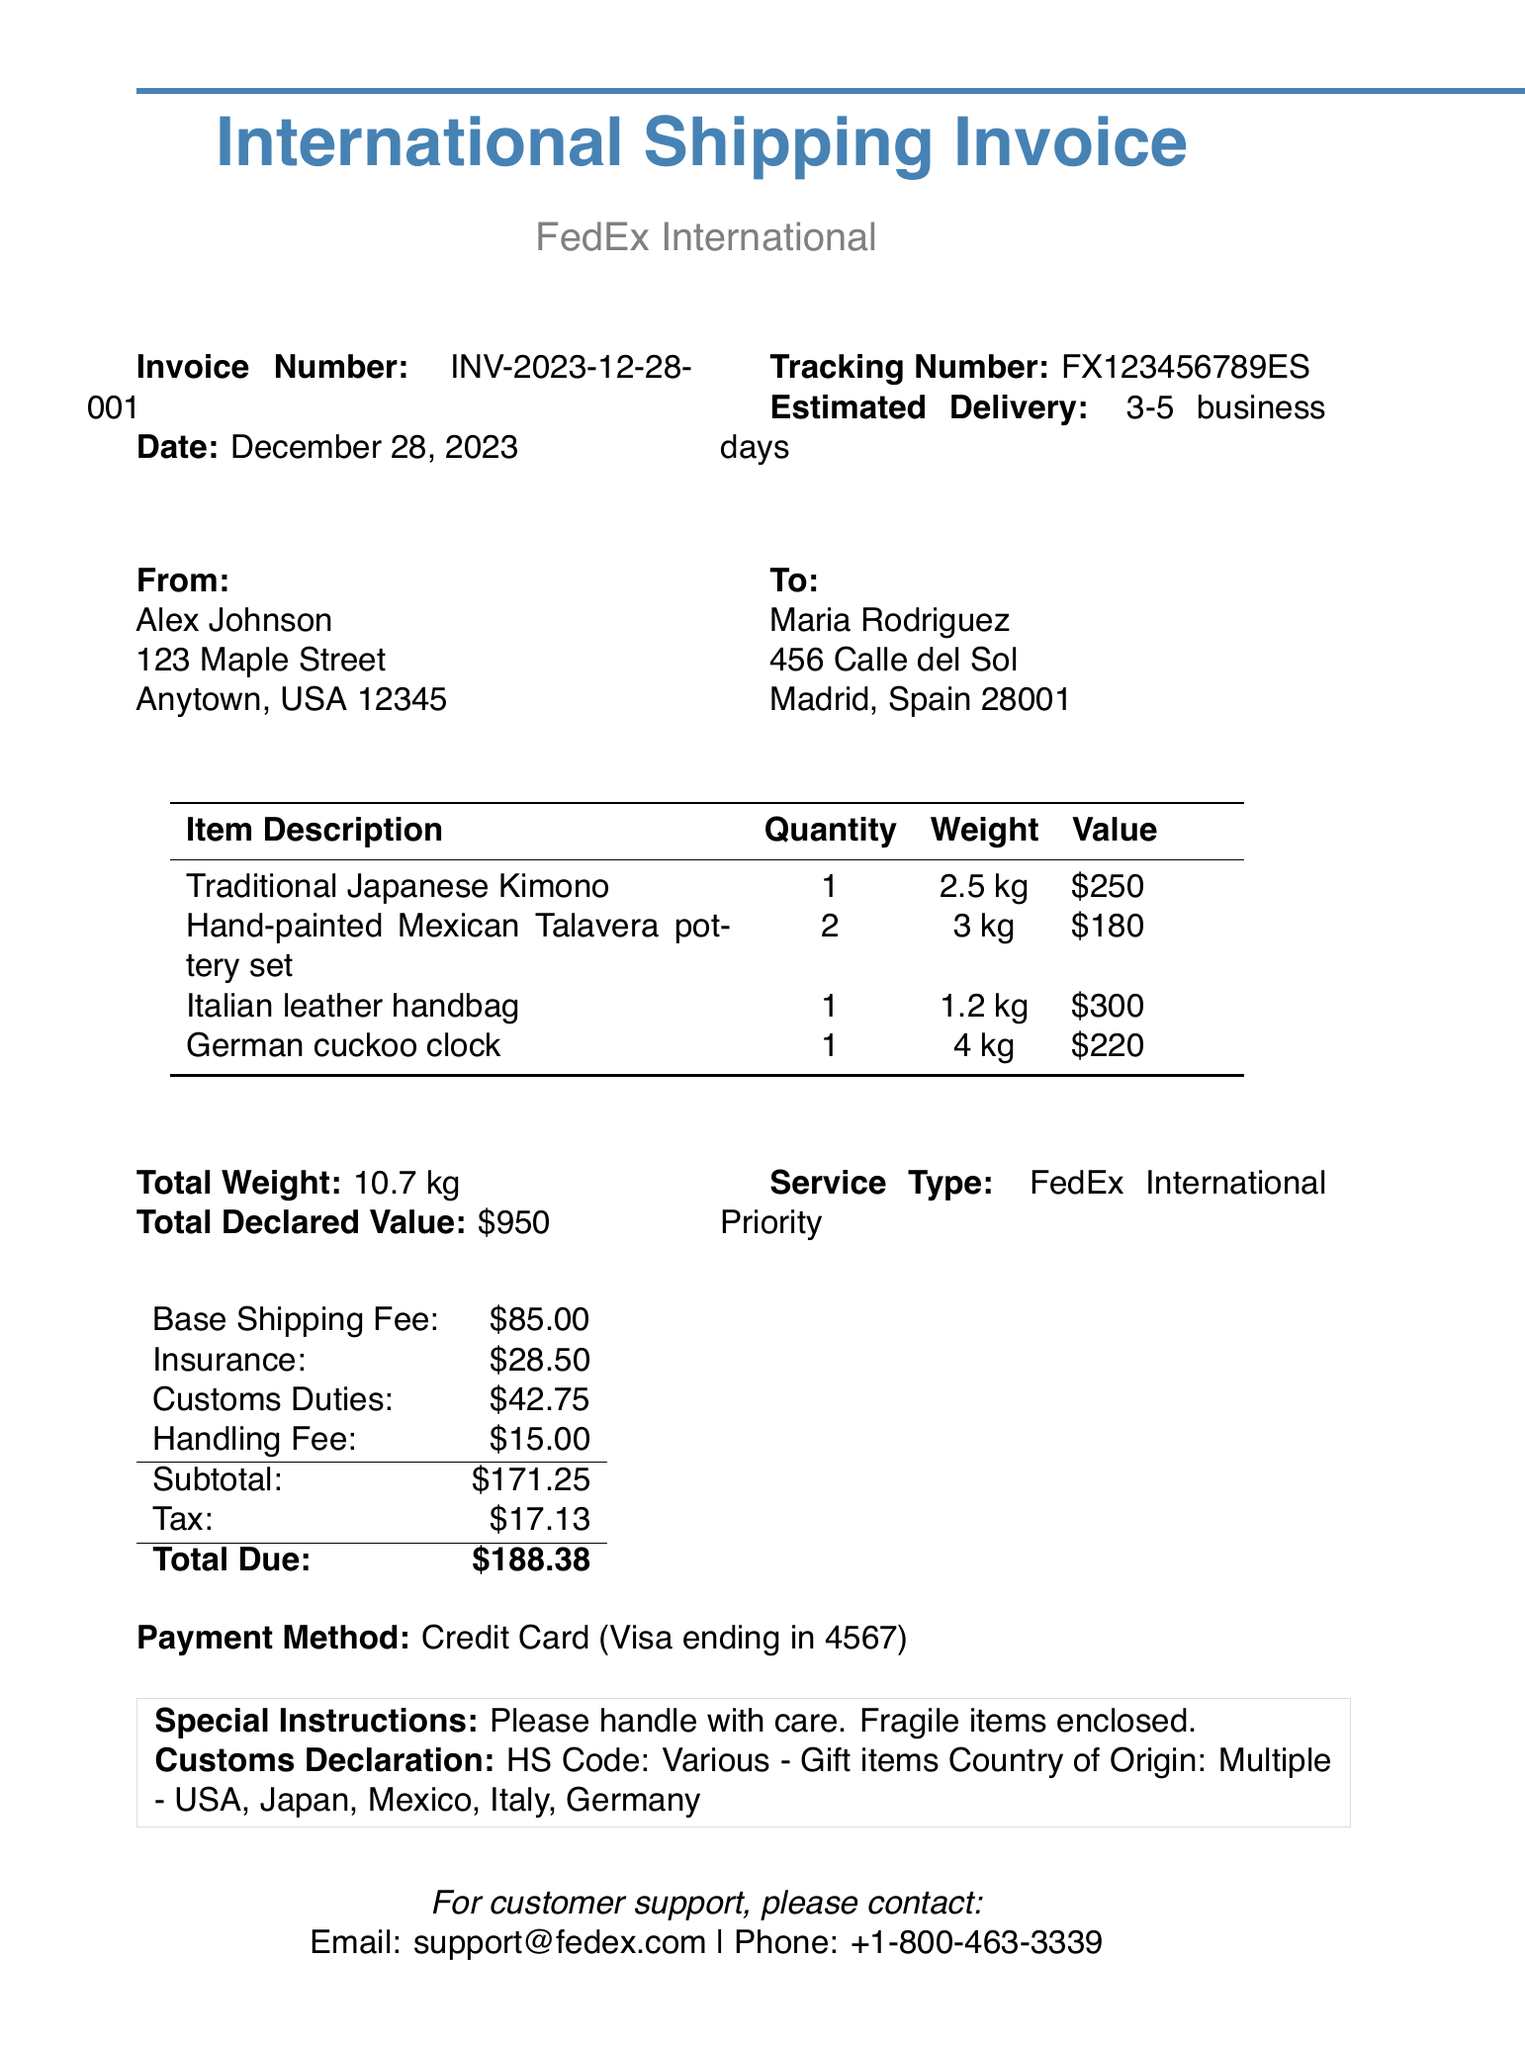What is the invoice number? The invoice number is specified at the top of the document, which is INV-2023-12-28-001.
Answer: INV-2023-12-28-001 What is the date of the invoice? The date of the invoice is recorded in the document as December 28, 2023.
Answer: December 28, 2023 Who is the sender? The sender's name and address are provided in the document as Alex Johnson at 123 Maple Street, Anytown, USA 12345.
Answer: Alex Johnson What is the tracking number? The tracking number for the shipment is mentioned in the document as FX123456789ES.
Answer: FX123456789ES What is the estimated delivery time? The estimated delivery time is noted as 3-5 business days.
Answer: 3-5 business days How many items are being shipped? The document lists four different items being shipped back to the recipient.
Answer: 4 What is the total due amount? The total amount that is due as specified at the end of the invoice is $188.38.
Answer: $188.38 What is the base shipping fee? The base shipping fee is detailed in the costs section as $85.00.
Answer: $85.00 What is the special instruction provided for the shipment? The document includes a special instruction stating to handle with care as fragile items are enclosed.
Answer: Please handle with care. Fragile items enclosed 